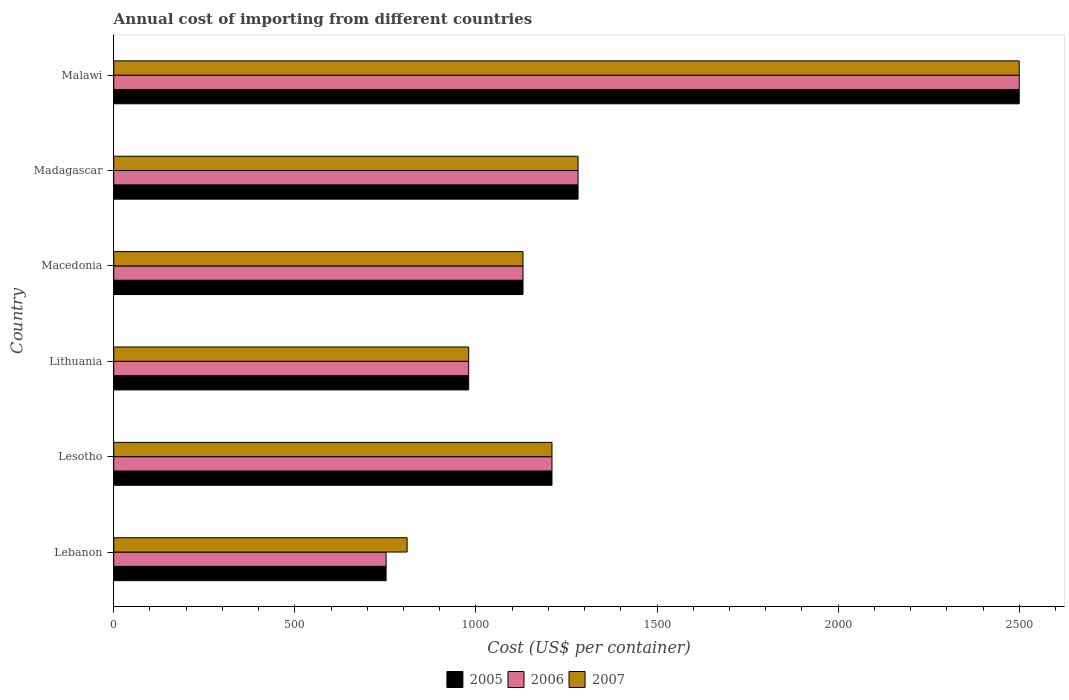How many different coloured bars are there?
Offer a very short reply. 3. How many groups of bars are there?
Provide a short and direct response. 6. Are the number of bars on each tick of the Y-axis equal?
Keep it short and to the point. Yes. How many bars are there on the 6th tick from the top?
Provide a succinct answer. 3. How many bars are there on the 1st tick from the bottom?
Offer a very short reply. 3. What is the label of the 5th group of bars from the top?
Your response must be concise. Lesotho. What is the total annual cost of importing in 2006 in Lesotho?
Keep it short and to the point. 1210. Across all countries, what is the maximum total annual cost of importing in 2006?
Provide a short and direct response. 2500. Across all countries, what is the minimum total annual cost of importing in 2006?
Provide a succinct answer. 752. In which country was the total annual cost of importing in 2006 maximum?
Your answer should be very brief. Malawi. In which country was the total annual cost of importing in 2006 minimum?
Give a very brief answer. Lebanon. What is the total total annual cost of importing in 2005 in the graph?
Offer a very short reply. 7854. What is the difference between the total annual cost of importing in 2005 in Lithuania and that in Madagascar?
Provide a short and direct response. -302. What is the difference between the total annual cost of importing in 2006 in Lesotho and the total annual cost of importing in 2007 in Lithuania?
Provide a short and direct response. 230. What is the average total annual cost of importing in 2005 per country?
Offer a very short reply. 1309. In how many countries, is the total annual cost of importing in 2007 greater than 600 US$?
Your response must be concise. 6. What is the ratio of the total annual cost of importing in 2006 in Lebanon to that in Madagascar?
Offer a very short reply. 0.59. Is the total annual cost of importing in 2006 in Lesotho less than that in Lithuania?
Give a very brief answer. No. Is the difference between the total annual cost of importing in 2007 in Lithuania and Macedonia greater than the difference between the total annual cost of importing in 2006 in Lithuania and Macedonia?
Your answer should be compact. No. What is the difference between the highest and the second highest total annual cost of importing in 2006?
Keep it short and to the point. 1218. What is the difference between the highest and the lowest total annual cost of importing in 2006?
Provide a short and direct response. 1748. In how many countries, is the total annual cost of importing in 2007 greater than the average total annual cost of importing in 2007 taken over all countries?
Provide a short and direct response. 1. What does the 3rd bar from the top in Lesotho represents?
Provide a succinct answer. 2005. What does the 3rd bar from the bottom in Madagascar represents?
Ensure brevity in your answer.  2007. Is it the case that in every country, the sum of the total annual cost of importing in 2006 and total annual cost of importing in 2005 is greater than the total annual cost of importing in 2007?
Your response must be concise. Yes. How many bars are there?
Offer a terse response. 18. Are all the bars in the graph horizontal?
Keep it short and to the point. Yes. Does the graph contain any zero values?
Your answer should be compact. No. Where does the legend appear in the graph?
Make the answer very short. Bottom center. How many legend labels are there?
Give a very brief answer. 3. What is the title of the graph?
Provide a succinct answer. Annual cost of importing from different countries. What is the label or title of the X-axis?
Offer a very short reply. Cost (US$ per container). What is the label or title of the Y-axis?
Give a very brief answer. Country. What is the Cost (US$ per container) in 2005 in Lebanon?
Offer a terse response. 752. What is the Cost (US$ per container) of 2006 in Lebanon?
Keep it short and to the point. 752. What is the Cost (US$ per container) of 2007 in Lebanon?
Keep it short and to the point. 810. What is the Cost (US$ per container) in 2005 in Lesotho?
Your answer should be very brief. 1210. What is the Cost (US$ per container) in 2006 in Lesotho?
Keep it short and to the point. 1210. What is the Cost (US$ per container) of 2007 in Lesotho?
Provide a short and direct response. 1210. What is the Cost (US$ per container) of 2005 in Lithuania?
Offer a very short reply. 980. What is the Cost (US$ per container) of 2006 in Lithuania?
Provide a succinct answer. 980. What is the Cost (US$ per container) in 2007 in Lithuania?
Offer a terse response. 980. What is the Cost (US$ per container) of 2005 in Macedonia?
Your response must be concise. 1130. What is the Cost (US$ per container) in 2006 in Macedonia?
Your answer should be compact. 1130. What is the Cost (US$ per container) in 2007 in Macedonia?
Make the answer very short. 1130. What is the Cost (US$ per container) in 2005 in Madagascar?
Provide a short and direct response. 1282. What is the Cost (US$ per container) in 2006 in Madagascar?
Provide a short and direct response. 1282. What is the Cost (US$ per container) of 2007 in Madagascar?
Offer a very short reply. 1282. What is the Cost (US$ per container) in 2005 in Malawi?
Offer a very short reply. 2500. What is the Cost (US$ per container) of 2006 in Malawi?
Make the answer very short. 2500. What is the Cost (US$ per container) of 2007 in Malawi?
Offer a very short reply. 2500. Across all countries, what is the maximum Cost (US$ per container) of 2005?
Keep it short and to the point. 2500. Across all countries, what is the maximum Cost (US$ per container) of 2006?
Your response must be concise. 2500. Across all countries, what is the maximum Cost (US$ per container) in 2007?
Provide a short and direct response. 2500. Across all countries, what is the minimum Cost (US$ per container) in 2005?
Your answer should be compact. 752. Across all countries, what is the minimum Cost (US$ per container) in 2006?
Make the answer very short. 752. Across all countries, what is the minimum Cost (US$ per container) of 2007?
Ensure brevity in your answer.  810. What is the total Cost (US$ per container) of 2005 in the graph?
Make the answer very short. 7854. What is the total Cost (US$ per container) of 2006 in the graph?
Your response must be concise. 7854. What is the total Cost (US$ per container) in 2007 in the graph?
Provide a short and direct response. 7912. What is the difference between the Cost (US$ per container) of 2005 in Lebanon and that in Lesotho?
Your response must be concise. -458. What is the difference between the Cost (US$ per container) in 2006 in Lebanon and that in Lesotho?
Your answer should be very brief. -458. What is the difference between the Cost (US$ per container) in 2007 in Lebanon and that in Lesotho?
Your answer should be compact. -400. What is the difference between the Cost (US$ per container) of 2005 in Lebanon and that in Lithuania?
Your answer should be compact. -228. What is the difference between the Cost (US$ per container) of 2006 in Lebanon and that in Lithuania?
Your answer should be compact. -228. What is the difference between the Cost (US$ per container) in 2007 in Lebanon and that in Lithuania?
Your answer should be compact. -170. What is the difference between the Cost (US$ per container) of 2005 in Lebanon and that in Macedonia?
Your response must be concise. -378. What is the difference between the Cost (US$ per container) of 2006 in Lebanon and that in Macedonia?
Offer a terse response. -378. What is the difference between the Cost (US$ per container) in 2007 in Lebanon and that in Macedonia?
Offer a very short reply. -320. What is the difference between the Cost (US$ per container) of 2005 in Lebanon and that in Madagascar?
Make the answer very short. -530. What is the difference between the Cost (US$ per container) of 2006 in Lebanon and that in Madagascar?
Your answer should be compact. -530. What is the difference between the Cost (US$ per container) in 2007 in Lebanon and that in Madagascar?
Offer a very short reply. -472. What is the difference between the Cost (US$ per container) in 2005 in Lebanon and that in Malawi?
Offer a terse response. -1748. What is the difference between the Cost (US$ per container) of 2006 in Lebanon and that in Malawi?
Give a very brief answer. -1748. What is the difference between the Cost (US$ per container) in 2007 in Lebanon and that in Malawi?
Provide a short and direct response. -1690. What is the difference between the Cost (US$ per container) of 2005 in Lesotho and that in Lithuania?
Give a very brief answer. 230. What is the difference between the Cost (US$ per container) in 2006 in Lesotho and that in Lithuania?
Your answer should be very brief. 230. What is the difference between the Cost (US$ per container) in 2007 in Lesotho and that in Lithuania?
Ensure brevity in your answer.  230. What is the difference between the Cost (US$ per container) in 2007 in Lesotho and that in Macedonia?
Your response must be concise. 80. What is the difference between the Cost (US$ per container) of 2005 in Lesotho and that in Madagascar?
Offer a very short reply. -72. What is the difference between the Cost (US$ per container) in 2006 in Lesotho and that in Madagascar?
Provide a short and direct response. -72. What is the difference between the Cost (US$ per container) of 2007 in Lesotho and that in Madagascar?
Make the answer very short. -72. What is the difference between the Cost (US$ per container) in 2005 in Lesotho and that in Malawi?
Your response must be concise. -1290. What is the difference between the Cost (US$ per container) in 2006 in Lesotho and that in Malawi?
Offer a very short reply. -1290. What is the difference between the Cost (US$ per container) of 2007 in Lesotho and that in Malawi?
Offer a terse response. -1290. What is the difference between the Cost (US$ per container) in 2005 in Lithuania and that in Macedonia?
Your answer should be very brief. -150. What is the difference between the Cost (US$ per container) in 2006 in Lithuania and that in Macedonia?
Give a very brief answer. -150. What is the difference between the Cost (US$ per container) of 2007 in Lithuania and that in Macedonia?
Give a very brief answer. -150. What is the difference between the Cost (US$ per container) of 2005 in Lithuania and that in Madagascar?
Provide a succinct answer. -302. What is the difference between the Cost (US$ per container) in 2006 in Lithuania and that in Madagascar?
Your answer should be very brief. -302. What is the difference between the Cost (US$ per container) in 2007 in Lithuania and that in Madagascar?
Your answer should be compact. -302. What is the difference between the Cost (US$ per container) in 2005 in Lithuania and that in Malawi?
Keep it short and to the point. -1520. What is the difference between the Cost (US$ per container) in 2006 in Lithuania and that in Malawi?
Keep it short and to the point. -1520. What is the difference between the Cost (US$ per container) in 2007 in Lithuania and that in Malawi?
Provide a short and direct response. -1520. What is the difference between the Cost (US$ per container) in 2005 in Macedonia and that in Madagascar?
Your answer should be very brief. -152. What is the difference between the Cost (US$ per container) of 2006 in Macedonia and that in Madagascar?
Your response must be concise. -152. What is the difference between the Cost (US$ per container) of 2007 in Macedonia and that in Madagascar?
Your answer should be compact. -152. What is the difference between the Cost (US$ per container) in 2005 in Macedonia and that in Malawi?
Keep it short and to the point. -1370. What is the difference between the Cost (US$ per container) of 2006 in Macedonia and that in Malawi?
Provide a succinct answer. -1370. What is the difference between the Cost (US$ per container) of 2007 in Macedonia and that in Malawi?
Ensure brevity in your answer.  -1370. What is the difference between the Cost (US$ per container) of 2005 in Madagascar and that in Malawi?
Your response must be concise. -1218. What is the difference between the Cost (US$ per container) in 2006 in Madagascar and that in Malawi?
Your response must be concise. -1218. What is the difference between the Cost (US$ per container) in 2007 in Madagascar and that in Malawi?
Keep it short and to the point. -1218. What is the difference between the Cost (US$ per container) in 2005 in Lebanon and the Cost (US$ per container) in 2006 in Lesotho?
Make the answer very short. -458. What is the difference between the Cost (US$ per container) of 2005 in Lebanon and the Cost (US$ per container) of 2007 in Lesotho?
Your answer should be compact. -458. What is the difference between the Cost (US$ per container) in 2006 in Lebanon and the Cost (US$ per container) in 2007 in Lesotho?
Offer a terse response. -458. What is the difference between the Cost (US$ per container) of 2005 in Lebanon and the Cost (US$ per container) of 2006 in Lithuania?
Your response must be concise. -228. What is the difference between the Cost (US$ per container) of 2005 in Lebanon and the Cost (US$ per container) of 2007 in Lithuania?
Your answer should be compact. -228. What is the difference between the Cost (US$ per container) of 2006 in Lebanon and the Cost (US$ per container) of 2007 in Lithuania?
Your answer should be compact. -228. What is the difference between the Cost (US$ per container) of 2005 in Lebanon and the Cost (US$ per container) of 2006 in Macedonia?
Ensure brevity in your answer.  -378. What is the difference between the Cost (US$ per container) in 2005 in Lebanon and the Cost (US$ per container) in 2007 in Macedonia?
Offer a terse response. -378. What is the difference between the Cost (US$ per container) in 2006 in Lebanon and the Cost (US$ per container) in 2007 in Macedonia?
Offer a terse response. -378. What is the difference between the Cost (US$ per container) in 2005 in Lebanon and the Cost (US$ per container) in 2006 in Madagascar?
Give a very brief answer. -530. What is the difference between the Cost (US$ per container) of 2005 in Lebanon and the Cost (US$ per container) of 2007 in Madagascar?
Your answer should be compact. -530. What is the difference between the Cost (US$ per container) in 2006 in Lebanon and the Cost (US$ per container) in 2007 in Madagascar?
Your answer should be compact. -530. What is the difference between the Cost (US$ per container) in 2005 in Lebanon and the Cost (US$ per container) in 2006 in Malawi?
Keep it short and to the point. -1748. What is the difference between the Cost (US$ per container) of 2005 in Lebanon and the Cost (US$ per container) of 2007 in Malawi?
Make the answer very short. -1748. What is the difference between the Cost (US$ per container) in 2006 in Lebanon and the Cost (US$ per container) in 2007 in Malawi?
Provide a succinct answer. -1748. What is the difference between the Cost (US$ per container) of 2005 in Lesotho and the Cost (US$ per container) of 2006 in Lithuania?
Your answer should be compact. 230. What is the difference between the Cost (US$ per container) in 2005 in Lesotho and the Cost (US$ per container) in 2007 in Lithuania?
Provide a succinct answer. 230. What is the difference between the Cost (US$ per container) of 2006 in Lesotho and the Cost (US$ per container) of 2007 in Lithuania?
Offer a terse response. 230. What is the difference between the Cost (US$ per container) in 2005 in Lesotho and the Cost (US$ per container) in 2006 in Macedonia?
Your response must be concise. 80. What is the difference between the Cost (US$ per container) in 2006 in Lesotho and the Cost (US$ per container) in 2007 in Macedonia?
Provide a short and direct response. 80. What is the difference between the Cost (US$ per container) in 2005 in Lesotho and the Cost (US$ per container) in 2006 in Madagascar?
Ensure brevity in your answer.  -72. What is the difference between the Cost (US$ per container) in 2005 in Lesotho and the Cost (US$ per container) in 2007 in Madagascar?
Give a very brief answer. -72. What is the difference between the Cost (US$ per container) in 2006 in Lesotho and the Cost (US$ per container) in 2007 in Madagascar?
Provide a short and direct response. -72. What is the difference between the Cost (US$ per container) of 2005 in Lesotho and the Cost (US$ per container) of 2006 in Malawi?
Your answer should be compact. -1290. What is the difference between the Cost (US$ per container) in 2005 in Lesotho and the Cost (US$ per container) in 2007 in Malawi?
Offer a very short reply. -1290. What is the difference between the Cost (US$ per container) in 2006 in Lesotho and the Cost (US$ per container) in 2007 in Malawi?
Give a very brief answer. -1290. What is the difference between the Cost (US$ per container) of 2005 in Lithuania and the Cost (US$ per container) of 2006 in Macedonia?
Offer a very short reply. -150. What is the difference between the Cost (US$ per container) of 2005 in Lithuania and the Cost (US$ per container) of 2007 in Macedonia?
Your answer should be very brief. -150. What is the difference between the Cost (US$ per container) in 2006 in Lithuania and the Cost (US$ per container) in 2007 in Macedonia?
Offer a terse response. -150. What is the difference between the Cost (US$ per container) in 2005 in Lithuania and the Cost (US$ per container) in 2006 in Madagascar?
Keep it short and to the point. -302. What is the difference between the Cost (US$ per container) of 2005 in Lithuania and the Cost (US$ per container) of 2007 in Madagascar?
Offer a very short reply. -302. What is the difference between the Cost (US$ per container) of 2006 in Lithuania and the Cost (US$ per container) of 2007 in Madagascar?
Your answer should be compact. -302. What is the difference between the Cost (US$ per container) of 2005 in Lithuania and the Cost (US$ per container) of 2006 in Malawi?
Provide a succinct answer. -1520. What is the difference between the Cost (US$ per container) in 2005 in Lithuania and the Cost (US$ per container) in 2007 in Malawi?
Your response must be concise. -1520. What is the difference between the Cost (US$ per container) of 2006 in Lithuania and the Cost (US$ per container) of 2007 in Malawi?
Provide a short and direct response. -1520. What is the difference between the Cost (US$ per container) in 2005 in Macedonia and the Cost (US$ per container) in 2006 in Madagascar?
Offer a very short reply. -152. What is the difference between the Cost (US$ per container) of 2005 in Macedonia and the Cost (US$ per container) of 2007 in Madagascar?
Give a very brief answer. -152. What is the difference between the Cost (US$ per container) in 2006 in Macedonia and the Cost (US$ per container) in 2007 in Madagascar?
Provide a succinct answer. -152. What is the difference between the Cost (US$ per container) in 2005 in Macedonia and the Cost (US$ per container) in 2006 in Malawi?
Offer a terse response. -1370. What is the difference between the Cost (US$ per container) of 2005 in Macedonia and the Cost (US$ per container) of 2007 in Malawi?
Your answer should be compact. -1370. What is the difference between the Cost (US$ per container) of 2006 in Macedonia and the Cost (US$ per container) of 2007 in Malawi?
Provide a succinct answer. -1370. What is the difference between the Cost (US$ per container) in 2005 in Madagascar and the Cost (US$ per container) in 2006 in Malawi?
Your answer should be very brief. -1218. What is the difference between the Cost (US$ per container) of 2005 in Madagascar and the Cost (US$ per container) of 2007 in Malawi?
Give a very brief answer. -1218. What is the difference between the Cost (US$ per container) in 2006 in Madagascar and the Cost (US$ per container) in 2007 in Malawi?
Ensure brevity in your answer.  -1218. What is the average Cost (US$ per container) of 2005 per country?
Your answer should be compact. 1309. What is the average Cost (US$ per container) in 2006 per country?
Ensure brevity in your answer.  1309. What is the average Cost (US$ per container) in 2007 per country?
Keep it short and to the point. 1318.67. What is the difference between the Cost (US$ per container) in 2005 and Cost (US$ per container) in 2006 in Lebanon?
Keep it short and to the point. 0. What is the difference between the Cost (US$ per container) in 2005 and Cost (US$ per container) in 2007 in Lebanon?
Offer a very short reply. -58. What is the difference between the Cost (US$ per container) in 2006 and Cost (US$ per container) in 2007 in Lebanon?
Offer a very short reply. -58. What is the difference between the Cost (US$ per container) of 2005 and Cost (US$ per container) of 2006 in Lesotho?
Provide a short and direct response. 0. What is the difference between the Cost (US$ per container) in 2005 and Cost (US$ per container) in 2007 in Lesotho?
Offer a terse response. 0. What is the difference between the Cost (US$ per container) of 2006 and Cost (US$ per container) of 2007 in Lesotho?
Provide a succinct answer. 0. What is the difference between the Cost (US$ per container) of 2005 and Cost (US$ per container) of 2006 in Lithuania?
Offer a terse response. 0. What is the difference between the Cost (US$ per container) of 2005 and Cost (US$ per container) of 2007 in Lithuania?
Provide a short and direct response. 0. What is the difference between the Cost (US$ per container) of 2006 and Cost (US$ per container) of 2007 in Lithuania?
Give a very brief answer. 0. What is the difference between the Cost (US$ per container) of 2005 and Cost (US$ per container) of 2006 in Macedonia?
Offer a terse response. 0. What is the difference between the Cost (US$ per container) of 2005 and Cost (US$ per container) of 2007 in Macedonia?
Provide a short and direct response. 0. What is the difference between the Cost (US$ per container) of 2006 and Cost (US$ per container) of 2007 in Macedonia?
Provide a short and direct response. 0. What is the difference between the Cost (US$ per container) in 2005 and Cost (US$ per container) in 2006 in Malawi?
Keep it short and to the point. 0. What is the ratio of the Cost (US$ per container) in 2005 in Lebanon to that in Lesotho?
Your answer should be compact. 0.62. What is the ratio of the Cost (US$ per container) in 2006 in Lebanon to that in Lesotho?
Your answer should be very brief. 0.62. What is the ratio of the Cost (US$ per container) of 2007 in Lebanon to that in Lesotho?
Ensure brevity in your answer.  0.67. What is the ratio of the Cost (US$ per container) of 2005 in Lebanon to that in Lithuania?
Provide a short and direct response. 0.77. What is the ratio of the Cost (US$ per container) in 2006 in Lebanon to that in Lithuania?
Ensure brevity in your answer.  0.77. What is the ratio of the Cost (US$ per container) in 2007 in Lebanon to that in Lithuania?
Your answer should be compact. 0.83. What is the ratio of the Cost (US$ per container) in 2005 in Lebanon to that in Macedonia?
Offer a very short reply. 0.67. What is the ratio of the Cost (US$ per container) in 2006 in Lebanon to that in Macedonia?
Provide a short and direct response. 0.67. What is the ratio of the Cost (US$ per container) of 2007 in Lebanon to that in Macedonia?
Offer a very short reply. 0.72. What is the ratio of the Cost (US$ per container) in 2005 in Lebanon to that in Madagascar?
Provide a succinct answer. 0.59. What is the ratio of the Cost (US$ per container) of 2006 in Lebanon to that in Madagascar?
Ensure brevity in your answer.  0.59. What is the ratio of the Cost (US$ per container) in 2007 in Lebanon to that in Madagascar?
Your answer should be very brief. 0.63. What is the ratio of the Cost (US$ per container) of 2005 in Lebanon to that in Malawi?
Keep it short and to the point. 0.3. What is the ratio of the Cost (US$ per container) of 2006 in Lebanon to that in Malawi?
Give a very brief answer. 0.3. What is the ratio of the Cost (US$ per container) in 2007 in Lebanon to that in Malawi?
Keep it short and to the point. 0.32. What is the ratio of the Cost (US$ per container) in 2005 in Lesotho to that in Lithuania?
Provide a succinct answer. 1.23. What is the ratio of the Cost (US$ per container) in 2006 in Lesotho to that in Lithuania?
Your response must be concise. 1.23. What is the ratio of the Cost (US$ per container) of 2007 in Lesotho to that in Lithuania?
Provide a short and direct response. 1.23. What is the ratio of the Cost (US$ per container) in 2005 in Lesotho to that in Macedonia?
Your answer should be compact. 1.07. What is the ratio of the Cost (US$ per container) in 2006 in Lesotho to that in Macedonia?
Provide a short and direct response. 1.07. What is the ratio of the Cost (US$ per container) of 2007 in Lesotho to that in Macedonia?
Your response must be concise. 1.07. What is the ratio of the Cost (US$ per container) of 2005 in Lesotho to that in Madagascar?
Your answer should be very brief. 0.94. What is the ratio of the Cost (US$ per container) in 2006 in Lesotho to that in Madagascar?
Make the answer very short. 0.94. What is the ratio of the Cost (US$ per container) of 2007 in Lesotho to that in Madagascar?
Provide a succinct answer. 0.94. What is the ratio of the Cost (US$ per container) of 2005 in Lesotho to that in Malawi?
Keep it short and to the point. 0.48. What is the ratio of the Cost (US$ per container) in 2006 in Lesotho to that in Malawi?
Give a very brief answer. 0.48. What is the ratio of the Cost (US$ per container) of 2007 in Lesotho to that in Malawi?
Provide a succinct answer. 0.48. What is the ratio of the Cost (US$ per container) in 2005 in Lithuania to that in Macedonia?
Your answer should be compact. 0.87. What is the ratio of the Cost (US$ per container) in 2006 in Lithuania to that in Macedonia?
Provide a succinct answer. 0.87. What is the ratio of the Cost (US$ per container) in 2007 in Lithuania to that in Macedonia?
Ensure brevity in your answer.  0.87. What is the ratio of the Cost (US$ per container) of 2005 in Lithuania to that in Madagascar?
Offer a very short reply. 0.76. What is the ratio of the Cost (US$ per container) in 2006 in Lithuania to that in Madagascar?
Your answer should be very brief. 0.76. What is the ratio of the Cost (US$ per container) in 2007 in Lithuania to that in Madagascar?
Keep it short and to the point. 0.76. What is the ratio of the Cost (US$ per container) of 2005 in Lithuania to that in Malawi?
Give a very brief answer. 0.39. What is the ratio of the Cost (US$ per container) of 2006 in Lithuania to that in Malawi?
Your answer should be compact. 0.39. What is the ratio of the Cost (US$ per container) in 2007 in Lithuania to that in Malawi?
Offer a very short reply. 0.39. What is the ratio of the Cost (US$ per container) of 2005 in Macedonia to that in Madagascar?
Offer a terse response. 0.88. What is the ratio of the Cost (US$ per container) in 2006 in Macedonia to that in Madagascar?
Ensure brevity in your answer.  0.88. What is the ratio of the Cost (US$ per container) in 2007 in Macedonia to that in Madagascar?
Offer a very short reply. 0.88. What is the ratio of the Cost (US$ per container) of 2005 in Macedonia to that in Malawi?
Your answer should be very brief. 0.45. What is the ratio of the Cost (US$ per container) in 2006 in Macedonia to that in Malawi?
Offer a very short reply. 0.45. What is the ratio of the Cost (US$ per container) in 2007 in Macedonia to that in Malawi?
Ensure brevity in your answer.  0.45. What is the ratio of the Cost (US$ per container) of 2005 in Madagascar to that in Malawi?
Offer a terse response. 0.51. What is the ratio of the Cost (US$ per container) of 2006 in Madagascar to that in Malawi?
Provide a short and direct response. 0.51. What is the ratio of the Cost (US$ per container) of 2007 in Madagascar to that in Malawi?
Provide a short and direct response. 0.51. What is the difference between the highest and the second highest Cost (US$ per container) in 2005?
Offer a terse response. 1218. What is the difference between the highest and the second highest Cost (US$ per container) in 2006?
Provide a succinct answer. 1218. What is the difference between the highest and the second highest Cost (US$ per container) in 2007?
Keep it short and to the point. 1218. What is the difference between the highest and the lowest Cost (US$ per container) of 2005?
Provide a succinct answer. 1748. What is the difference between the highest and the lowest Cost (US$ per container) of 2006?
Offer a terse response. 1748. What is the difference between the highest and the lowest Cost (US$ per container) of 2007?
Your answer should be very brief. 1690. 